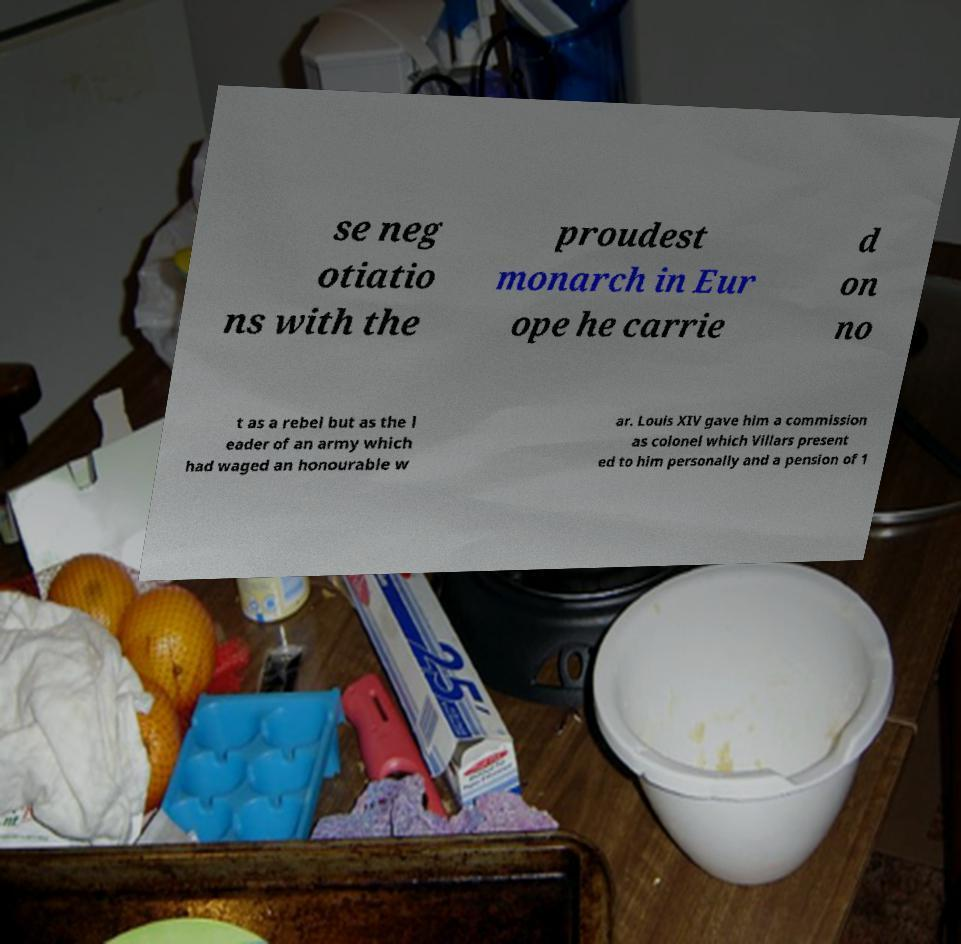I need the written content from this picture converted into text. Can you do that? se neg otiatio ns with the proudest monarch in Eur ope he carrie d on no t as a rebel but as the l eader of an army which had waged an honourable w ar. Louis XIV gave him a commission as colonel which Villars present ed to him personally and a pension of 1 